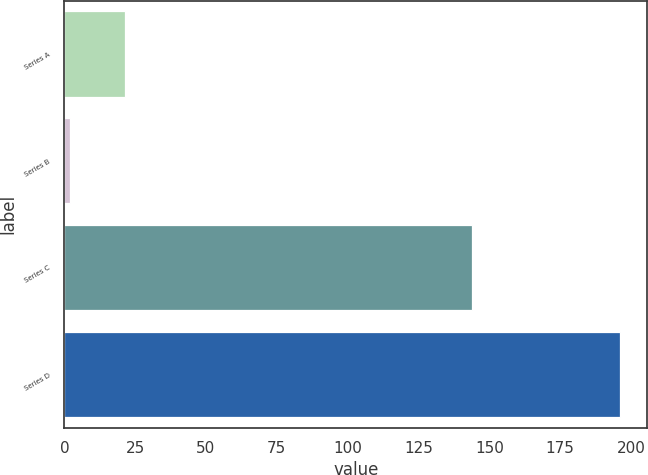<chart> <loc_0><loc_0><loc_500><loc_500><bar_chart><fcel>Series A<fcel>Series B<fcel>Series C<fcel>Series D<nl><fcel>21.4<fcel>2<fcel>144<fcel>196<nl></chart> 